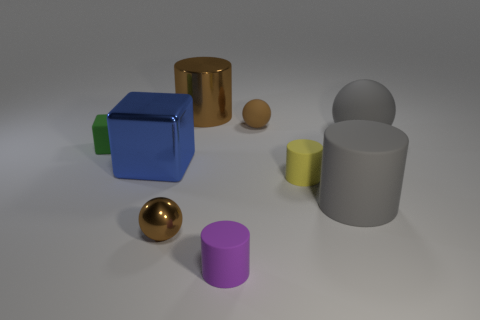What material is the big object that is the same shape as the small green object?
Ensure brevity in your answer.  Metal. The large matte ball has what color?
Your response must be concise. Gray. Is the color of the tiny matte ball the same as the metallic block?
Make the answer very short. No. What number of metal objects are brown cylinders or small yellow objects?
Provide a short and direct response. 1. There is a tiny green rubber object that is in front of the small brown ball behind the small metallic ball; is there a small matte object that is behind it?
Offer a terse response. Yes. There is a yellow thing that is made of the same material as the small purple cylinder; what size is it?
Offer a terse response. Small. Are there any metal balls behind the tiny brown rubber ball?
Keep it short and to the point. No. There is a small rubber object behind the tiny green block; are there any big rubber things behind it?
Ensure brevity in your answer.  No. Do the blue metallic block that is to the left of the brown rubber thing and the brown sphere on the right side of the purple rubber thing have the same size?
Keep it short and to the point. No. What number of tiny objects are matte cylinders or blue matte balls?
Make the answer very short. 2. 